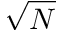Convert formula to latex. <formula><loc_0><loc_0><loc_500><loc_500>\sqrt { N }</formula> 